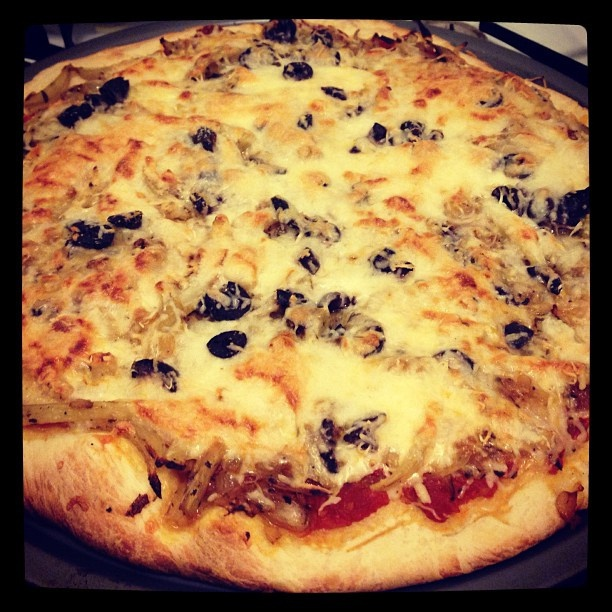Describe the objects in this image and their specific colors. I can see a pizza in orange, black, khaki, and brown tones in this image. 